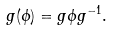<formula> <loc_0><loc_0><loc_500><loc_500>g ( \phi ) = g \phi g ^ { - 1 } .</formula> 